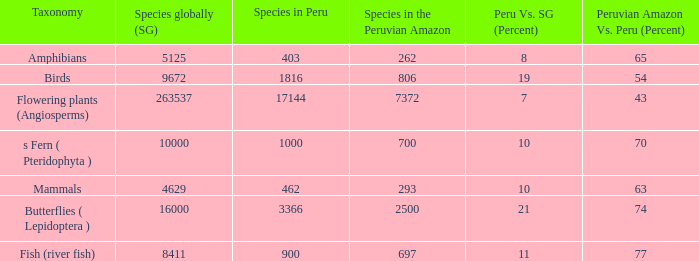What's the minimum species in the peruvian amazon with species in peru of 1000 700.0. 